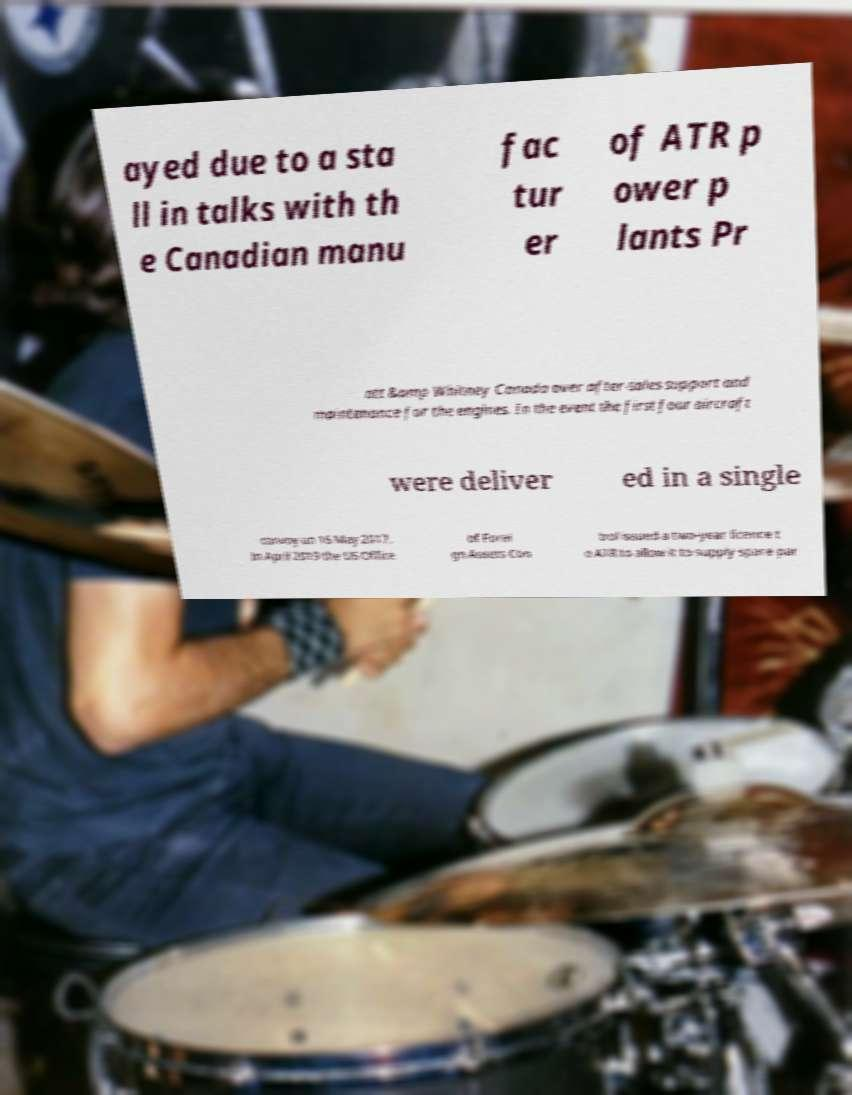Can you accurately transcribe the text from the provided image for me? ayed due to a sta ll in talks with th e Canadian manu fac tur er of ATR p ower p lants Pr att &amp Whitney Canada over after-sales support and maintenance for the engines. In the event the first four aircraft were deliver ed in a single convoy on 16 May 2017. In April 2019 the US Office of Forei gn Assets Con trol issued a two-year licence t o ATR to allow it to supply spare par 